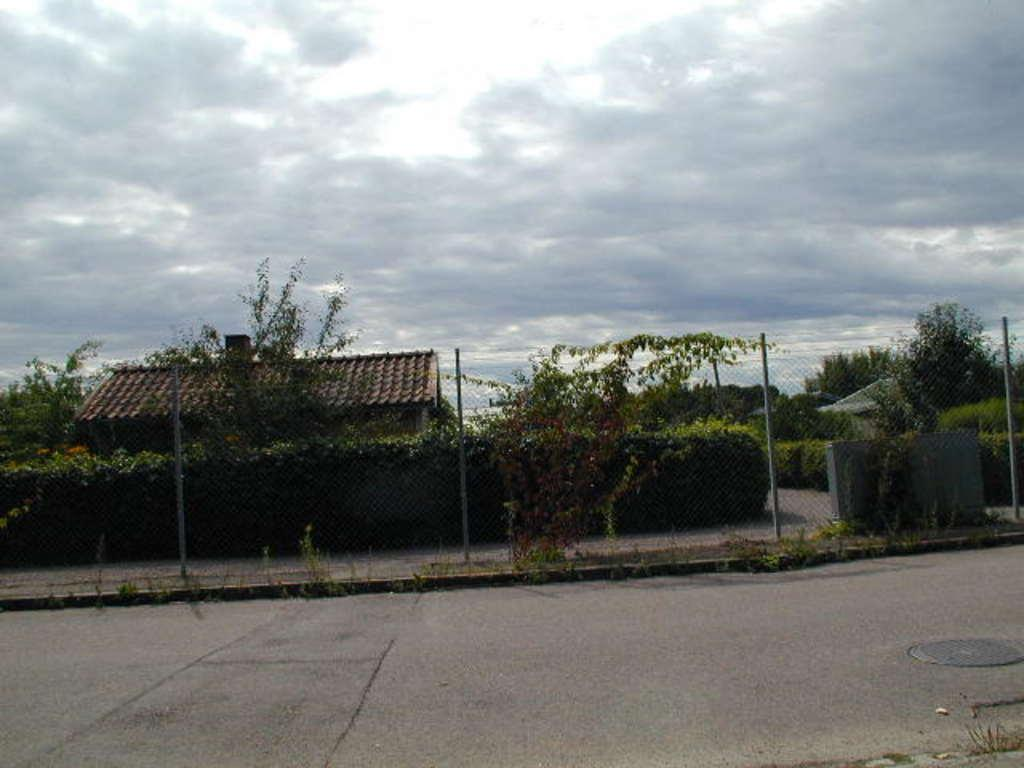What type of structures can be seen in the image? There are houses in the image. What are the vertical objects in the image? There are poles in the image. What type of vegetation is present in the image? There are trees, plants, and grass in the image. What might be used to separate properties in the image? There is a fence in the image. What else can be seen in the image besides the mentioned elements? There are other objects in the image. What is visible in the background of the image? The sky is visible in the background of the image. What type of protest is taking place in the image? There is no protest present in the image; it features houses, poles, trees, plants, grass, a fence, and other objects. How many balls can be seen in the image? There are no balls present in the image. 